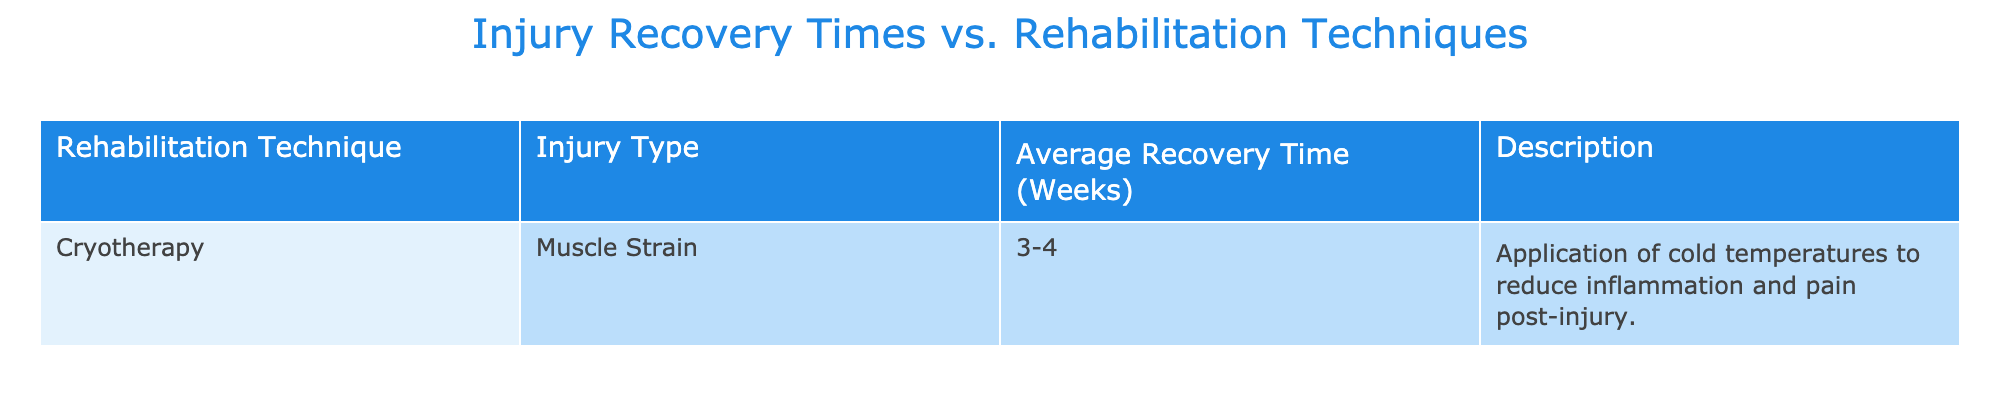What rehabilitation technique is used for muscle strain? The table lists the rehabilitation technique used for muscle strain, which is cryotherapy. This can be directly found under the "Rehabilitation Technique" column corresponding to "Muscle Strain."
Answer: Cryotherapy What is the average recovery time for a muscle strain using cryotherapy? The table shows that the average recovery time for a muscle strain when employing cryotherapy is 3-4 weeks. This can be found directly under the "Average Recovery Time (Weeks)" column.
Answer: 3-4 weeks Is the average recovery time for cryotherapy longer than 4 weeks? By examining the “Average Recovery Time (Weeks)” column for cryotherapy, it is indicated as 3-4 weeks. Since the maximum recovery time stated is 4 weeks, we can conclude that the recovery time is not longer than 4 weeks.
Answer: No Which injury type has the shortest average recovery time in the table? Since there is only one entry in the table, we observe that muscle strain is the only injury type, and its recovery time ranges from 3 to 4 weeks. Therefore, it is the shortest recovery time recorded.
Answer: Muscle Strain If an athlete uses cryotherapy for muscle strain, what is the range of their expected recovery time? The table specifies that the average recovery time for muscle strain using cryotherapy is stated as 3-4 weeks, indicating that an athlete could expect to recover anywhere within this time frame.
Answer: 3-4 weeks How many rehabilitation techniques are listed in the table? The table has only one rehabilitation technique listed, which is cryotherapy. Thus, the total number of techniques is one.
Answer: 1 Can we conclude that cryotherapy is effective for all types of injuries based on this table? The table only includes data for one type of injury—muscle strain—associated with cryotherapy. Therefore, we cannot make a generalized conclusion about its effectiveness for all injury types.
Answer: No What can we infer about the relationship between cryotherapy and inflammation reduction? The description in the table notes that cryotherapy involves the application of cold temperatures to reduce inflammation and pain post-injury. This implies a direct relationship where cryotherapy is used specifically for cooling and reducing these issues.
Answer: Reduces inflammation and pain 